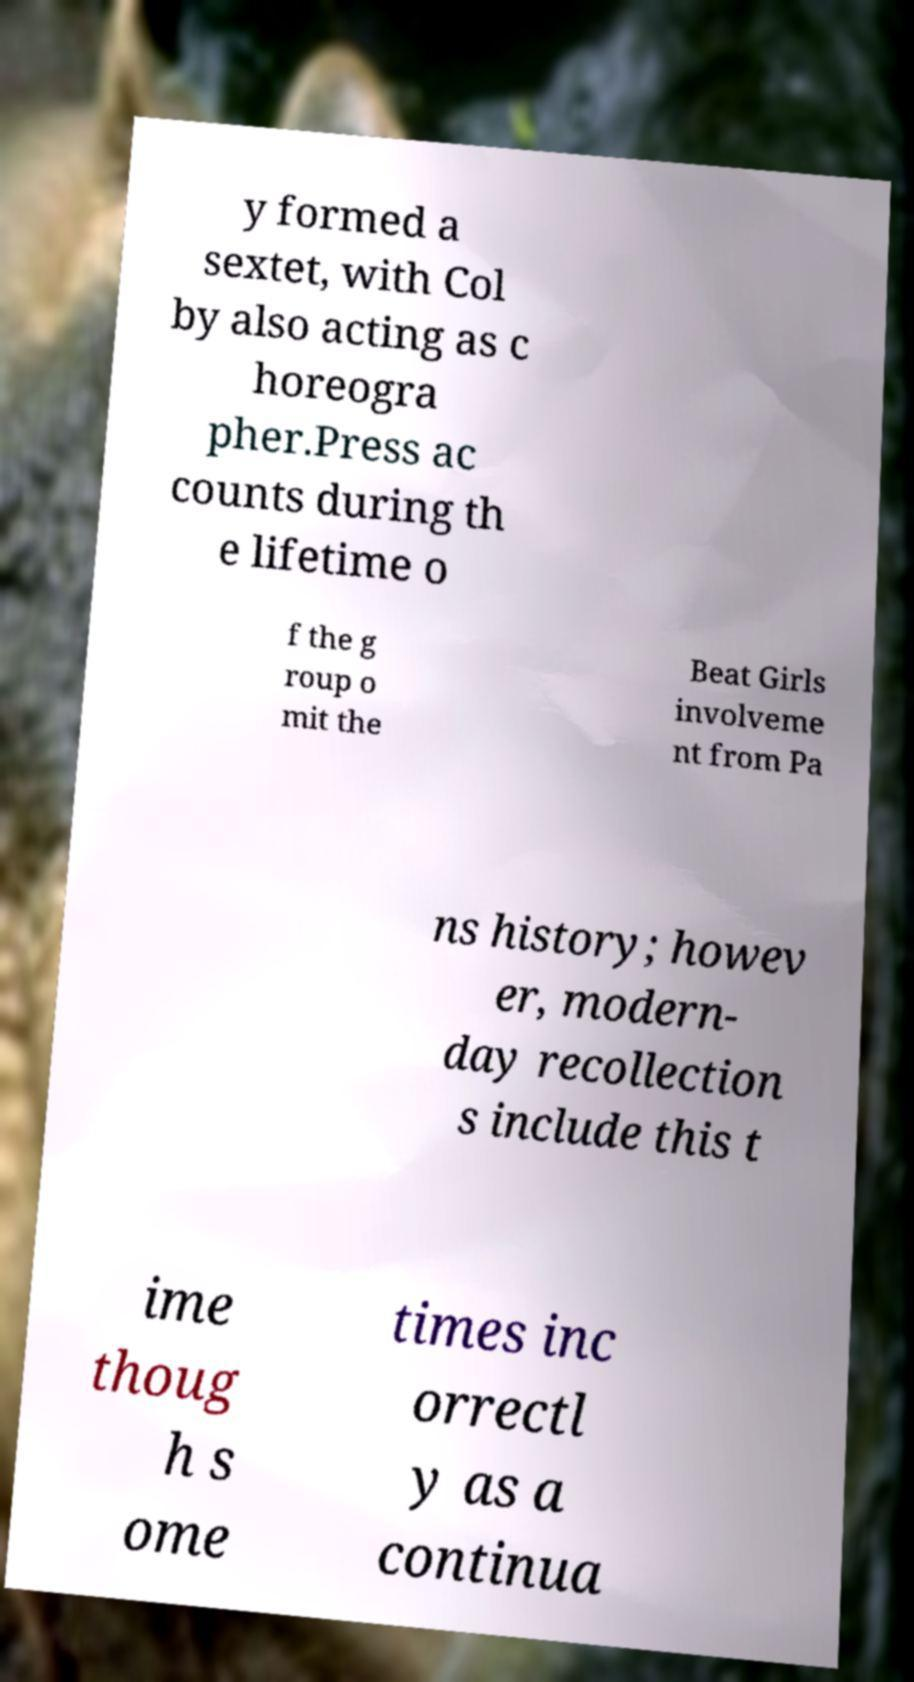Please read and relay the text visible in this image. What does it say? y formed a sextet, with Col by also acting as c horeogra pher.Press ac counts during th e lifetime o f the g roup o mit the Beat Girls involveme nt from Pa ns history; howev er, modern- day recollection s include this t ime thoug h s ome times inc orrectl y as a continua 